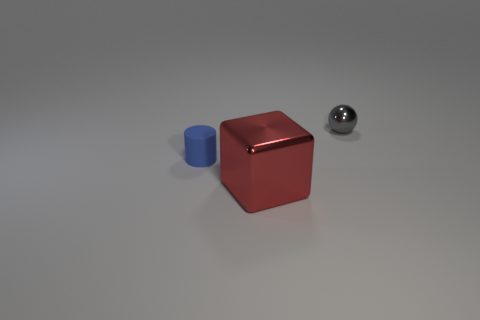Add 2 blue rubber things. How many objects exist? 5 Subtract all large red metal blocks. Subtract all gray shiny balls. How many objects are left? 1 Add 3 gray objects. How many gray objects are left? 4 Add 2 small gray shiny spheres. How many small gray shiny spheres exist? 3 Subtract 1 blue cylinders. How many objects are left? 2 